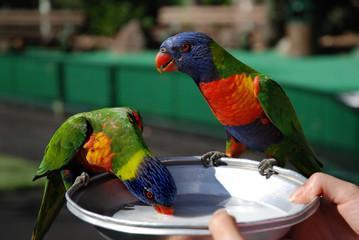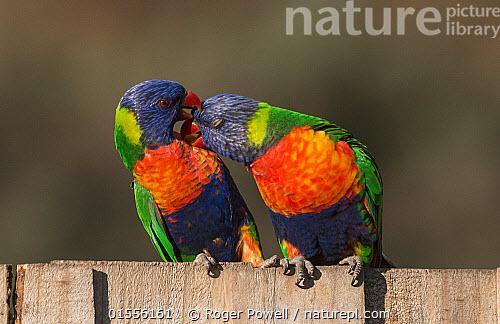The first image is the image on the left, the second image is the image on the right. For the images displayed, is the sentence "At least one brightly colored bird perches on a branch with pink flowers." factually correct? Answer yes or no. No. The first image is the image on the left, the second image is the image on the right. Assess this claim about the two images: "A blue-headed bird with non-spread wings is perched among dark pink flowers with tendril petals.". Correct or not? Answer yes or no. No. 